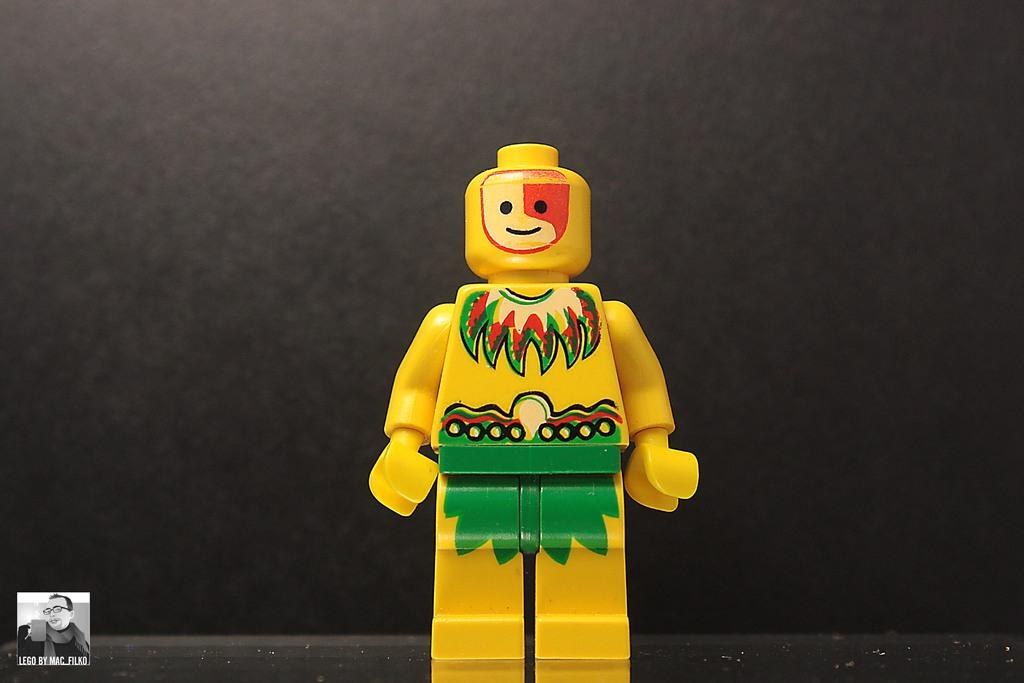What object can be seen in the image that is meant for play? There is a toy in the image. What type of visual representation is present in the image? There is a picture in the image. What type of written information is present in the image? There is text in the image. What color is the background of the image? The background of the image is gray in color. What type of waste is being disposed of in the image? There is no waste present in the image. What decision is being made in the image? There is no decision-making process depicted in the image. 